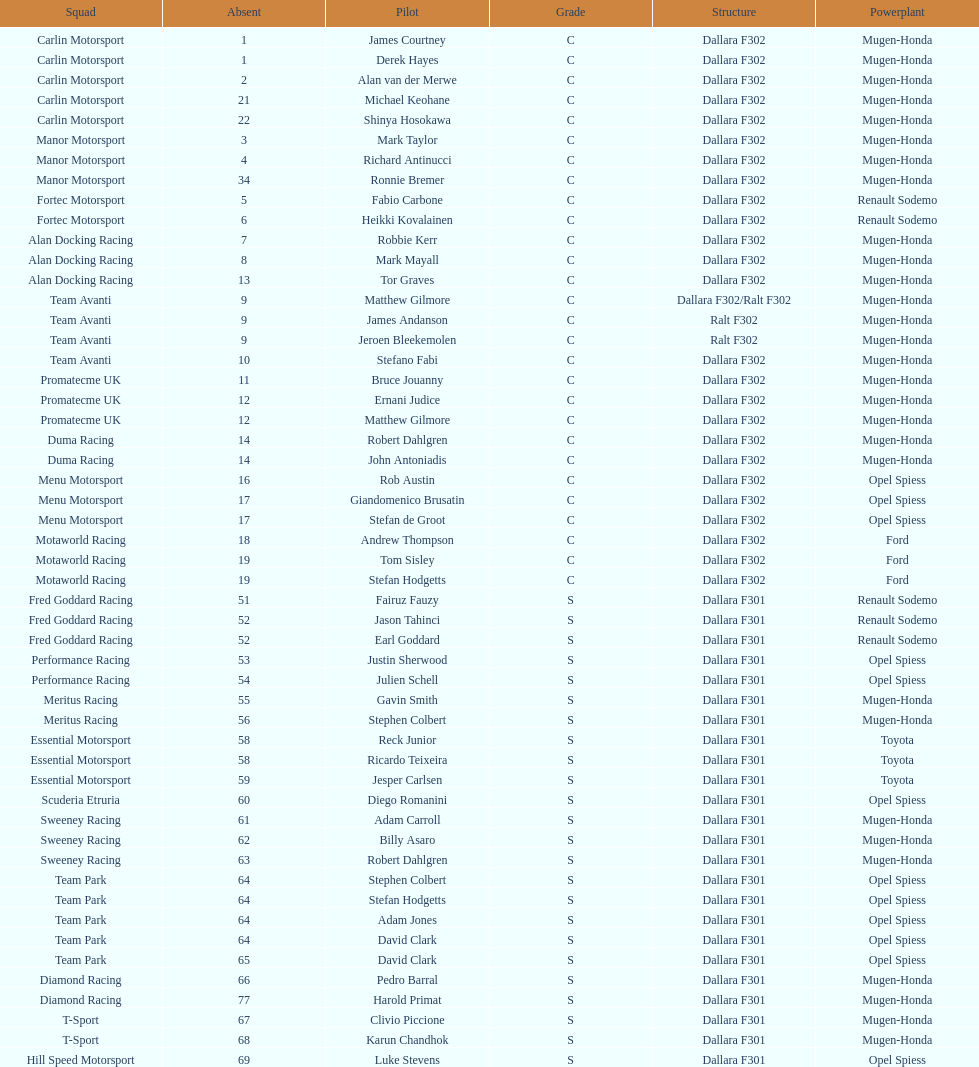The two drivers on t-sport are clivio piccione and what other driver? Karun Chandhok. 